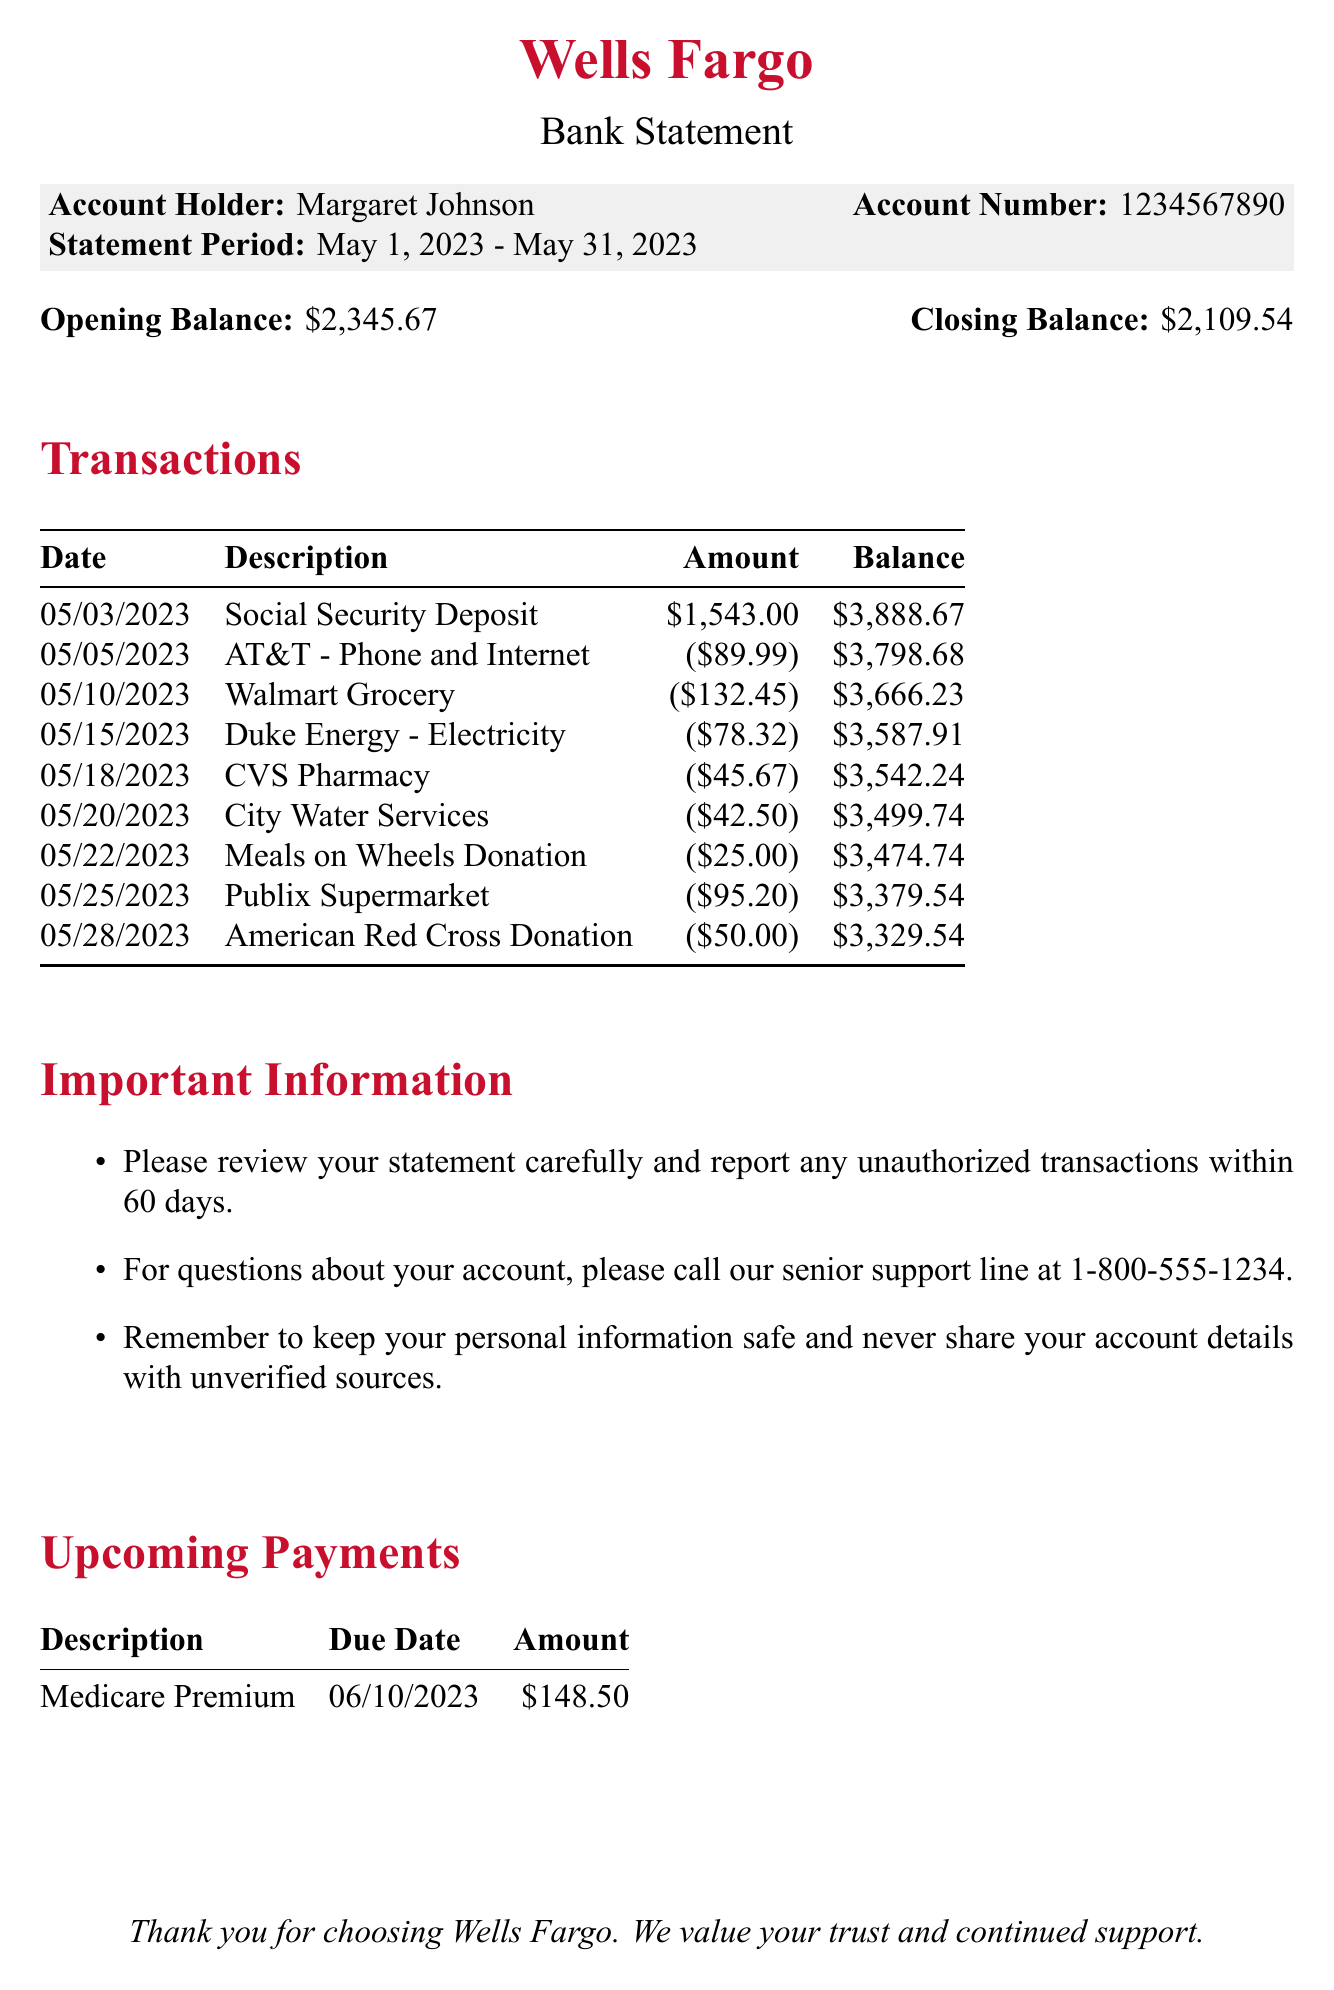What is the bank name? The bank name is stated at the top of the document before any other information.
Answer: Wells Fargo Who is the account holder? The account holder's name is displayed prominently in the account details section.
Answer: Margaret Johnson What is the statement period? The statement period indicates the time frame for the transactions listed, found in the account details.
Answer: May 1, 2023 - May 31, 2023 How much was the Social Security deposit? The amount for the Social Security deposit is explicitly stated in the transactions section.
Answer: 1543.00 What is the closing balance? The closing balance is summarized at the end of the transaction section.
Answer: 2109.54 What was the total amount spent on groceries? The total grocery expenses can be calculated by adding the amounts listed for Walmart and Publix during the statement period.
Answer: 227.65 What is the due date for the Medicare Premium payment? The due date for upcoming payments is listed in the upcoming payments section.
Answer: 06/10/2023 How many donations were made in May 2023? The number of donations is counted from the listed transactions under donations in the document.
Answer: 2 What is the contact number for account questions? The contact number is provided in the important information section for inquiries.
Answer: 1-800-555-1234 